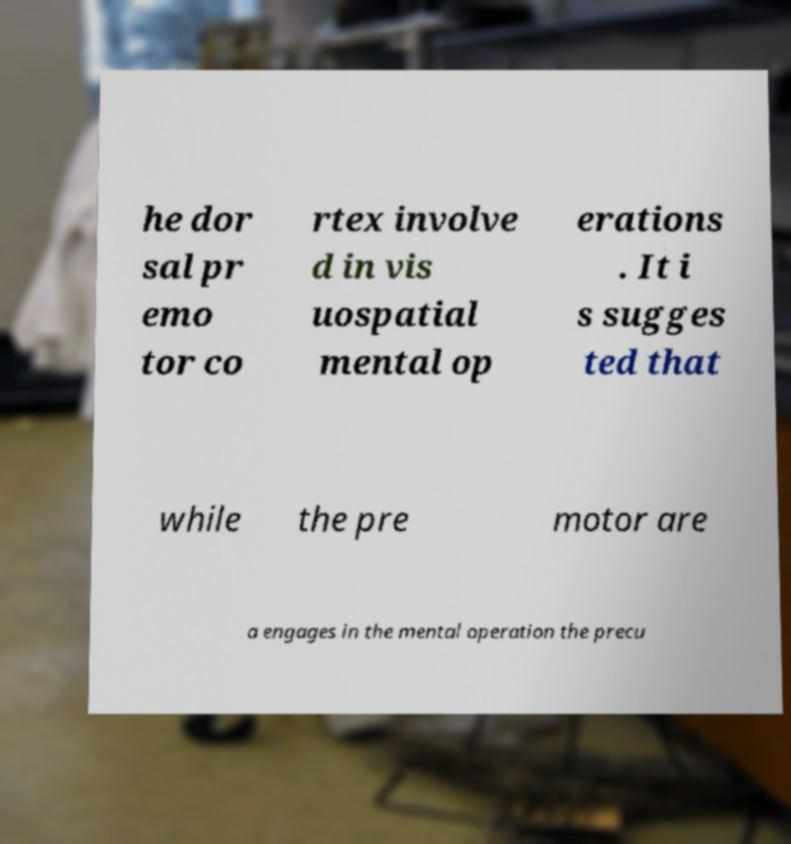What messages or text are displayed in this image? I need them in a readable, typed format. he dor sal pr emo tor co rtex involve d in vis uospatial mental op erations . It i s sugges ted that while the pre motor are a engages in the mental operation the precu 